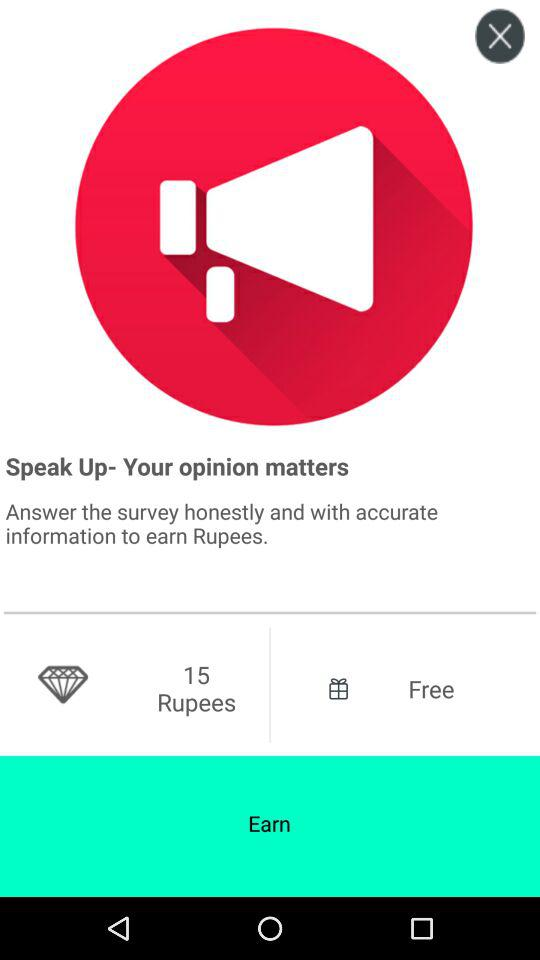How many more rupees can I earn by answering the survey?
Answer the question using a single word or phrase. 15 